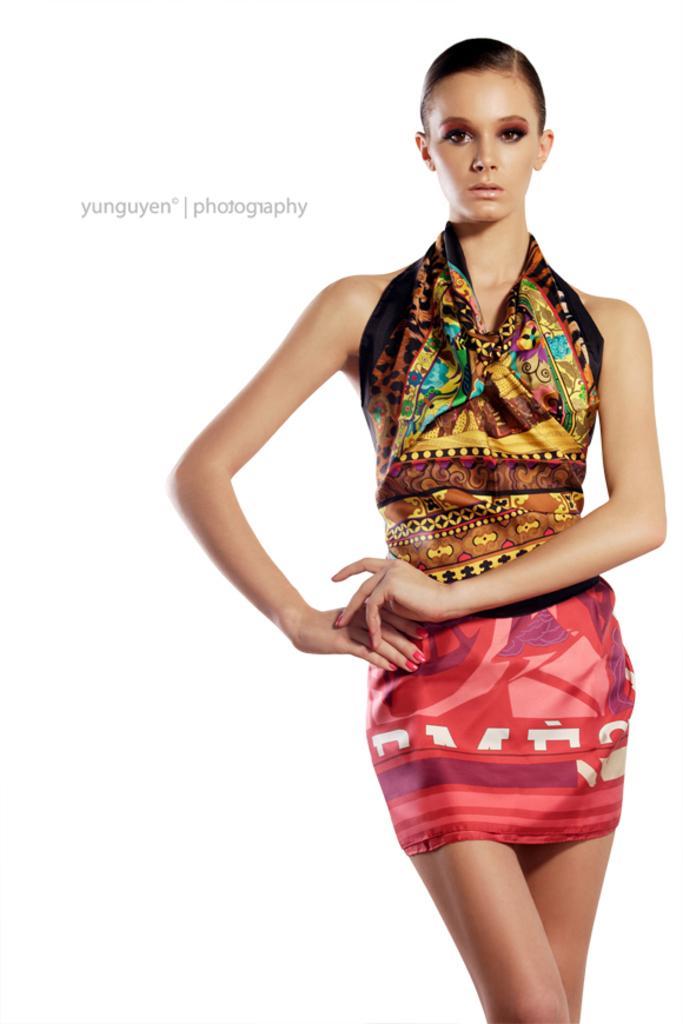Please provide a concise description of this image. In this image I can see a woman and the background is white in color. 